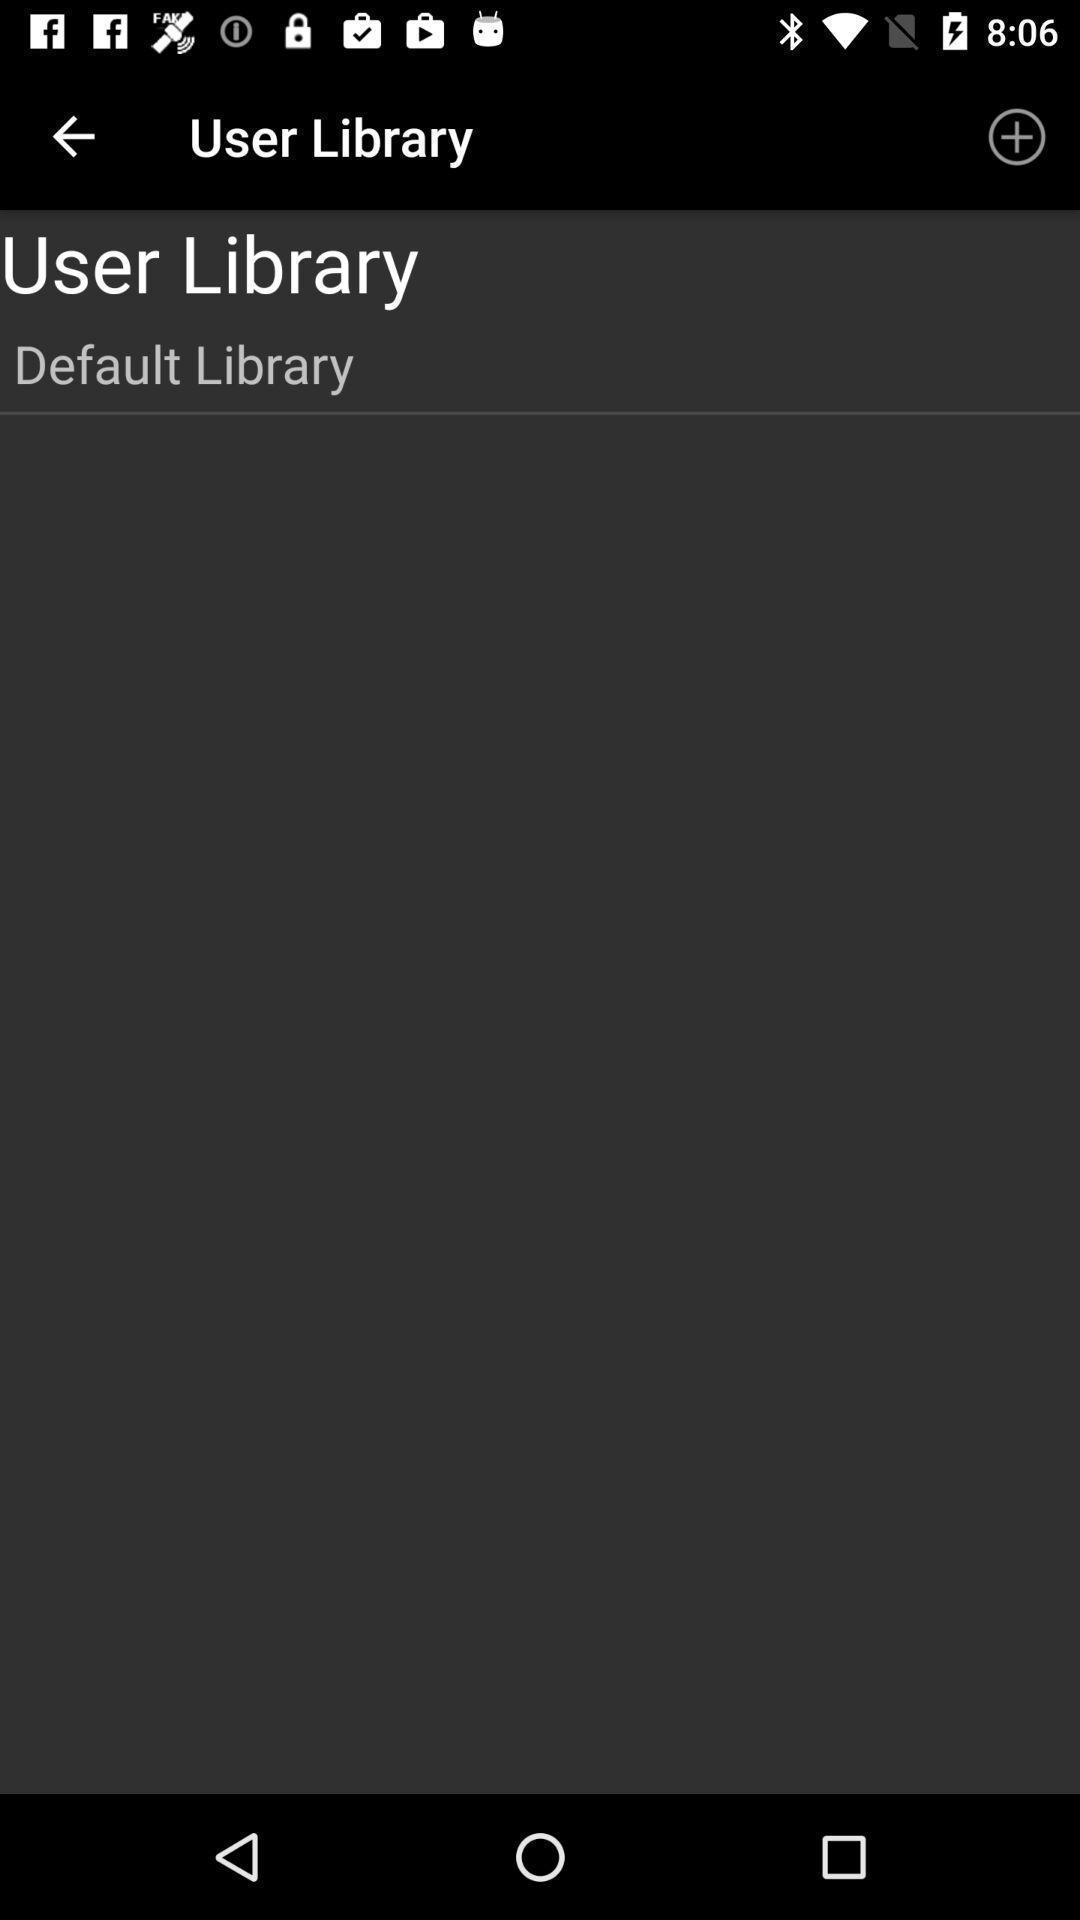What details can you identify in this image? Page showing user library. 